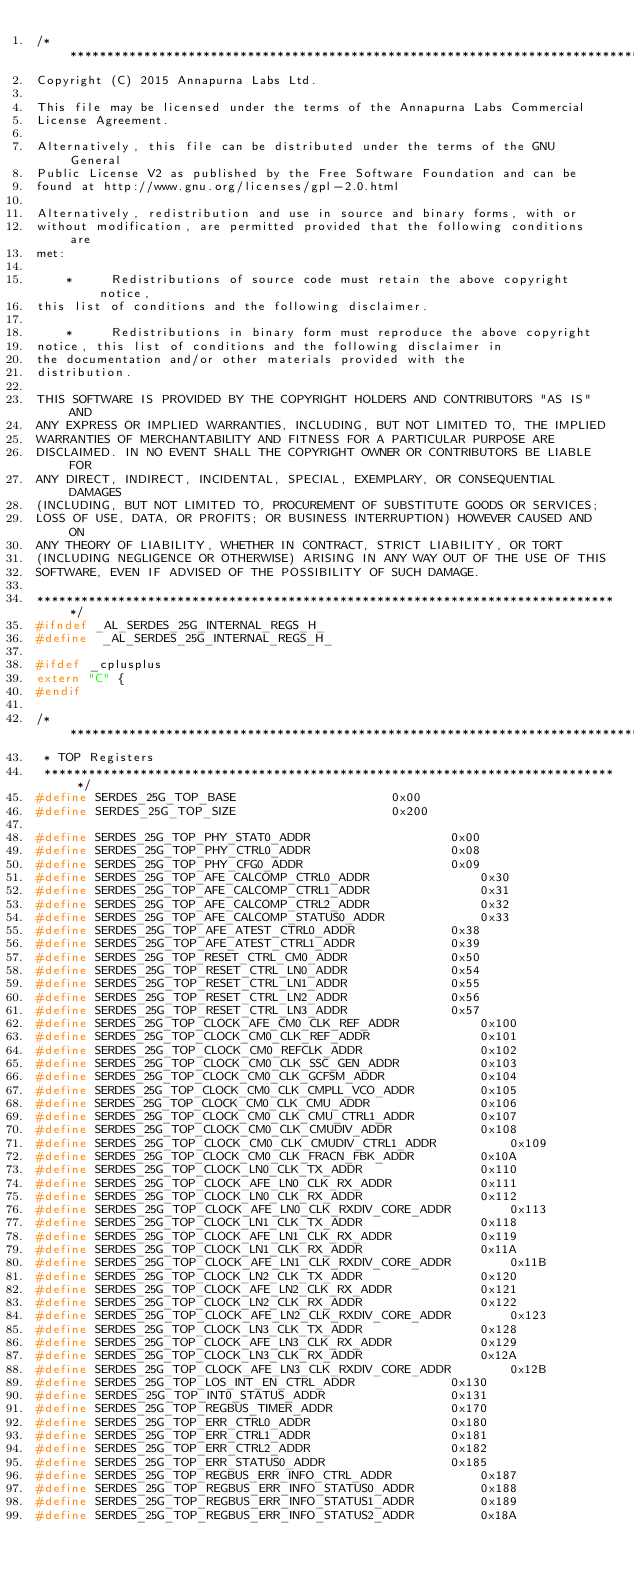<code> <loc_0><loc_0><loc_500><loc_500><_C_>/*******************************************************************************
Copyright (C) 2015 Annapurna Labs Ltd.

This file may be licensed under the terms of the Annapurna Labs Commercial
License Agreement.

Alternatively, this file can be distributed under the terms of the GNU General
Public License V2 as published by the Free Software Foundation and can be
found at http://www.gnu.org/licenses/gpl-2.0.html

Alternatively, redistribution and use in source and binary forms, with or
without modification, are permitted provided that the following conditions are
met:

    *     Redistributions of source code must retain the above copyright notice,
this list of conditions and the following disclaimer.

    *     Redistributions in binary form must reproduce the above copyright
notice, this list of conditions and the following disclaimer in
the documentation and/or other materials provided with the
distribution.

THIS SOFTWARE IS PROVIDED BY THE COPYRIGHT HOLDERS AND CONTRIBUTORS "AS IS" AND
ANY EXPRESS OR IMPLIED WARRANTIES, INCLUDING, BUT NOT LIMITED TO, THE IMPLIED
WARRANTIES OF MERCHANTABILITY AND FITNESS FOR A PARTICULAR PURPOSE ARE
DISCLAIMED. IN NO EVENT SHALL THE COPYRIGHT OWNER OR CONTRIBUTORS BE LIABLE FOR
ANY DIRECT, INDIRECT, INCIDENTAL, SPECIAL, EXEMPLARY, OR CONSEQUENTIAL DAMAGES
(INCLUDING, BUT NOT LIMITED TO, PROCUREMENT OF SUBSTITUTE GOODS OR SERVICES;
LOSS OF USE, DATA, OR PROFITS; OR BUSINESS INTERRUPTION) HOWEVER CAUSED AND ON
ANY THEORY OF LIABILITY, WHETHER IN CONTRACT, STRICT LIABILITY, OR TORT
(INCLUDING NEGLIGENCE OR OTHERWISE) ARISING IN ANY WAY OUT OF THE USE OF THIS
SOFTWARE, EVEN IF ADVISED OF THE POSSIBILITY OF SUCH DAMAGE.

*******************************************************************************/
#ifndef _AL_SERDES_25G_INTERNAL_REGS_H_
#define  _AL_SERDES_25G_INTERNAL_REGS_H_

#ifdef _cplusplus
extern "C" {
#endif

/*******************************************************************************
 * TOP Registers
 ******************************************************************************/
#define SERDES_25G_TOP_BASE						0x00
#define SERDES_25G_TOP_SIZE						0x200

#define SERDES_25G_TOP_PHY_STAT0_ADDR					0x00
#define SERDES_25G_TOP_PHY_CTRL0_ADDR					0x08
#define SERDES_25G_TOP_PHY_CFG0_ADDR					0x09
#define SERDES_25G_TOP_AFE_CALCOMP_CTRL0_ADDR				0x30
#define SERDES_25G_TOP_AFE_CALCOMP_CTRL1_ADDR				0x31
#define SERDES_25G_TOP_AFE_CALCOMP_CTRL2_ADDR				0x32
#define SERDES_25G_TOP_AFE_CALCOMP_STATUS0_ADDR				0x33
#define SERDES_25G_TOP_AFE_ATEST_CTRL0_ADDR				0x38
#define SERDES_25G_TOP_AFE_ATEST_CTRL1_ADDR				0x39
#define SERDES_25G_TOP_RESET_CTRL_CM0_ADDR				0x50
#define SERDES_25G_TOP_RESET_CTRL_LN0_ADDR				0x54
#define SERDES_25G_TOP_RESET_CTRL_LN1_ADDR				0x55
#define SERDES_25G_TOP_RESET_CTRL_LN2_ADDR				0x56
#define SERDES_25G_TOP_RESET_CTRL_LN3_ADDR				0x57
#define SERDES_25G_TOP_CLOCK_AFE_CM0_CLK_REF_ADDR			0x100
#define SERDES_25G_TOP_CLOCK_CM0_CLK_REF_ADDR				0x101
#define SERDES_25G_TOP_CLOCK_CM0_REFCLK_ADDR				0x102
#define SERDES_25G_TOP_CLOCK_CM0_CLK_SSC_GEN_ADDR			0x103
#define SERDES_25G_TOP_CLOCK_CM0_CLK_GCFSM_ADDR				0x104
#define SERDES_25G_TOP_CLOCK_CM0_CLK_CMPLL_VCO_ADDR			0x105
#define SERDES_25G_TOP_CLOCK_CM0_CLK_CMU_ADDR				0x106
#define SERDES_25G_TOP_CLOCK_CM0_CLK_CMU_CTRL1_ADDR			0x107
#define SERDES_25G_TOP_CLOCK_CM0_CLK_CMUDIV_ADDR			0x108
#define SERDES_25G_TOP_CLOCK_CM0_CLK_CMUDIV_CTRL1_ADDR			0x109
#define SERDES_25G_TOP_CLOCK_CM0_CLK_FRACN_FBK_ADDR			0x10A
#define SERDES_25G_TOP_CLOCK_LN0_CLK_TX_ADDR				0x110
#define SERDES_25G_TOP_CLOCK_AFE_LN0_CLK_RX_ADDR			0x111
#define SERDES_25G_TOP_CLOCK_LN0_CLK_RX_ADDR				0x112
#define SERDES_25G_TOP_CLOCK_AFE_LN0_CLK_RXDIV_CORE_ADDR		0x113
#define SERDES_25G_TOP_CLOCK_LN1_CLK_TX_ADDR				0x118
#define SERDES_25G_TOP_CLOCK_AFE_LN1_CLK_RX_ADDR			0x119
#define SERDES_25G_TOP_CLOCK_LN1_CLK_RX_ADDR				0x11A
#define SERDES_25G_TOP_CLOCK_AFE_LN1_CLK_RXDIV_CORE_ADDR		0x11B
#define SERDES_25G_TOP_CLOCK_LN2_CLK_TX_ADDR				0x120
#define SERDES_25G_TOP_CLOCK_AFE_LN2_CLK_RX_ADDR			0x121
#define SERDES_25G_TOP_CLOCK_LN2_CLK_RX_ADDR				0x122
#define SERDES_25G_TOP_CLOCK_AFE_LN2_CLK_RXDIV_CORE_ADDR		0x123
#define SERDES_25G_TOP_CLOCK_LN3_CLK_TX_ADDR				0x128
#define SERDES_25G_TOP_CLOCK_AFE_LN3_CLK_RX_ADDR			0x129
#define SERDES_25G_TOP_CLOCK_LN3_CLK_RX_ADDR				0x12A
#define SERDES_25G_TOP_CLOCK_AFE_LN3_CLK_RXDIV_CORE_ADDR		0x12B
#define SERDES_25G_TOP_LOS_INT_EN_CTRL_ADDR				0x130
#define SERDES_25G_TOP_INT0_STATUS_ADDR					0x131
#define SERDES_25G_TOP_REGBUS_TIMER_ADDR				0x170
#define SERDES_25G_TOP_ERR_CTRL0_ADDR					0x180
#define SERDES_25G_TOP_ERR_CTRL1_ADDR					0x181
#define SERDES_25G_TOP_ERR_CTRL2_ADDR					0x182
#define SERDES_25G_TOP_ERR_STATUS0_ADDR					0x185
#define SERDES_25G_TOP_REGBUS_ERR_INFO_CTRL_ADDR			0x187
#define SERDES_25G_TOP_REGBUS_ERR_INFO_STATUS0_ADDR			0x188
#define SERDES_25G_TOP_REGBUS_ERR_INFO_STATUS1_ADDR			0x189
#define SERDES_25G_TOP_REGBUS_ERR_INFO_STATUS2_ADDR			0x18A</code> 